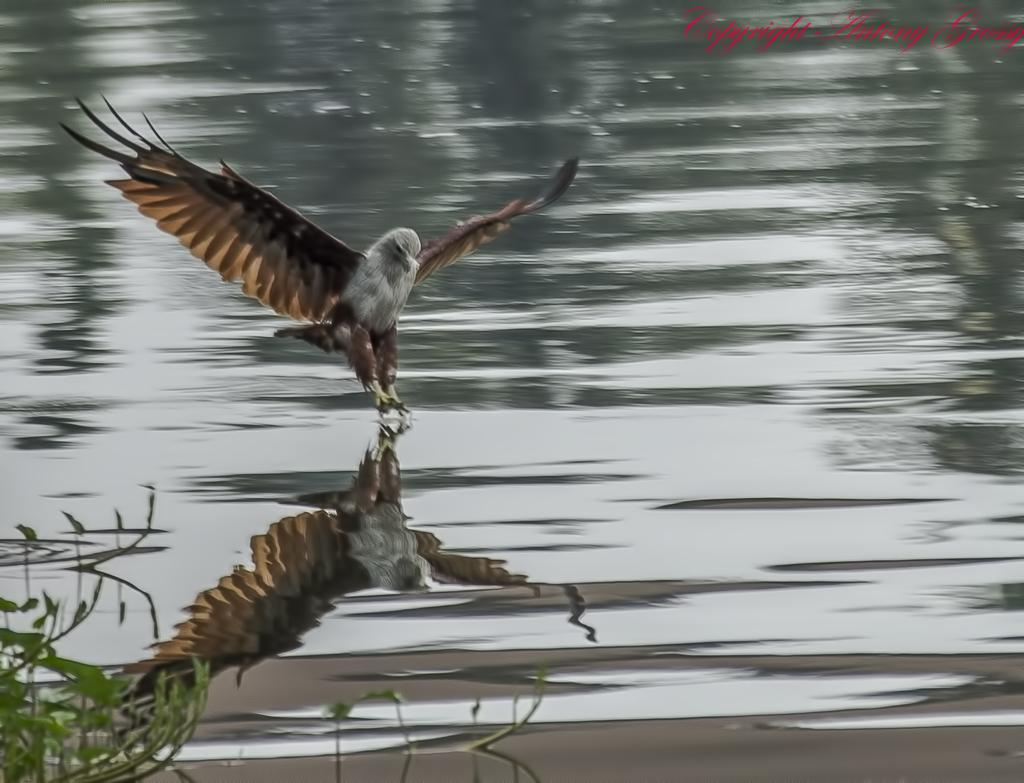What is the main subject in the foreground of the image? There is a bird in the foreground of the image. What is the bird's position relative to the water? The bird is above the water surface. What type of environment can be seen at the bottom of the image? There is greenery visible at the bottom of the image. What type of light can be seen reflecting off the bird's feathers in the image? There is no mention of light or its reflection in the provided facts, so we cannot determine the type of light present in the image. 